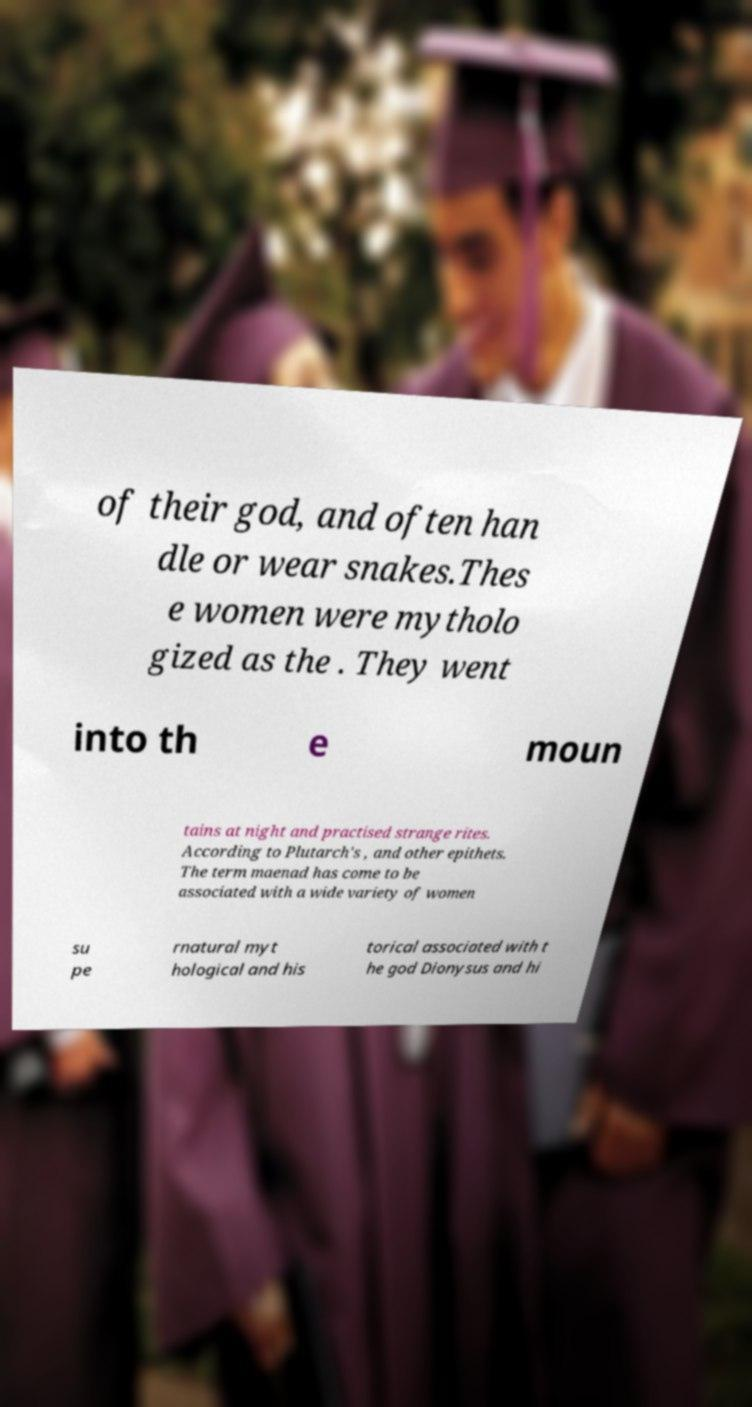Could you extract and type out the text from this image? of their god, and often han dle or wear snakes.Thes e women were mytholo gized as the . They went into th e moun tains at night and practised strange rites. According to Plutarch's , and other epithets. The term maenad has come to be associated with a wide variety of women su pe rnatural myt hological and his torical associated with t he god Dionysus and hi 